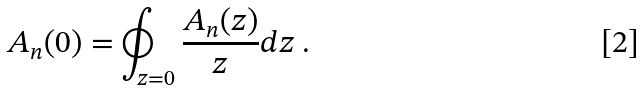<formula> <loc_0><loc_0><loc_500><loc_500>A _ { n } ( 0 ) = \oint _ { z = 0 } \frac { A _ { n } ( z ) } { z } d z \ .</formula> 